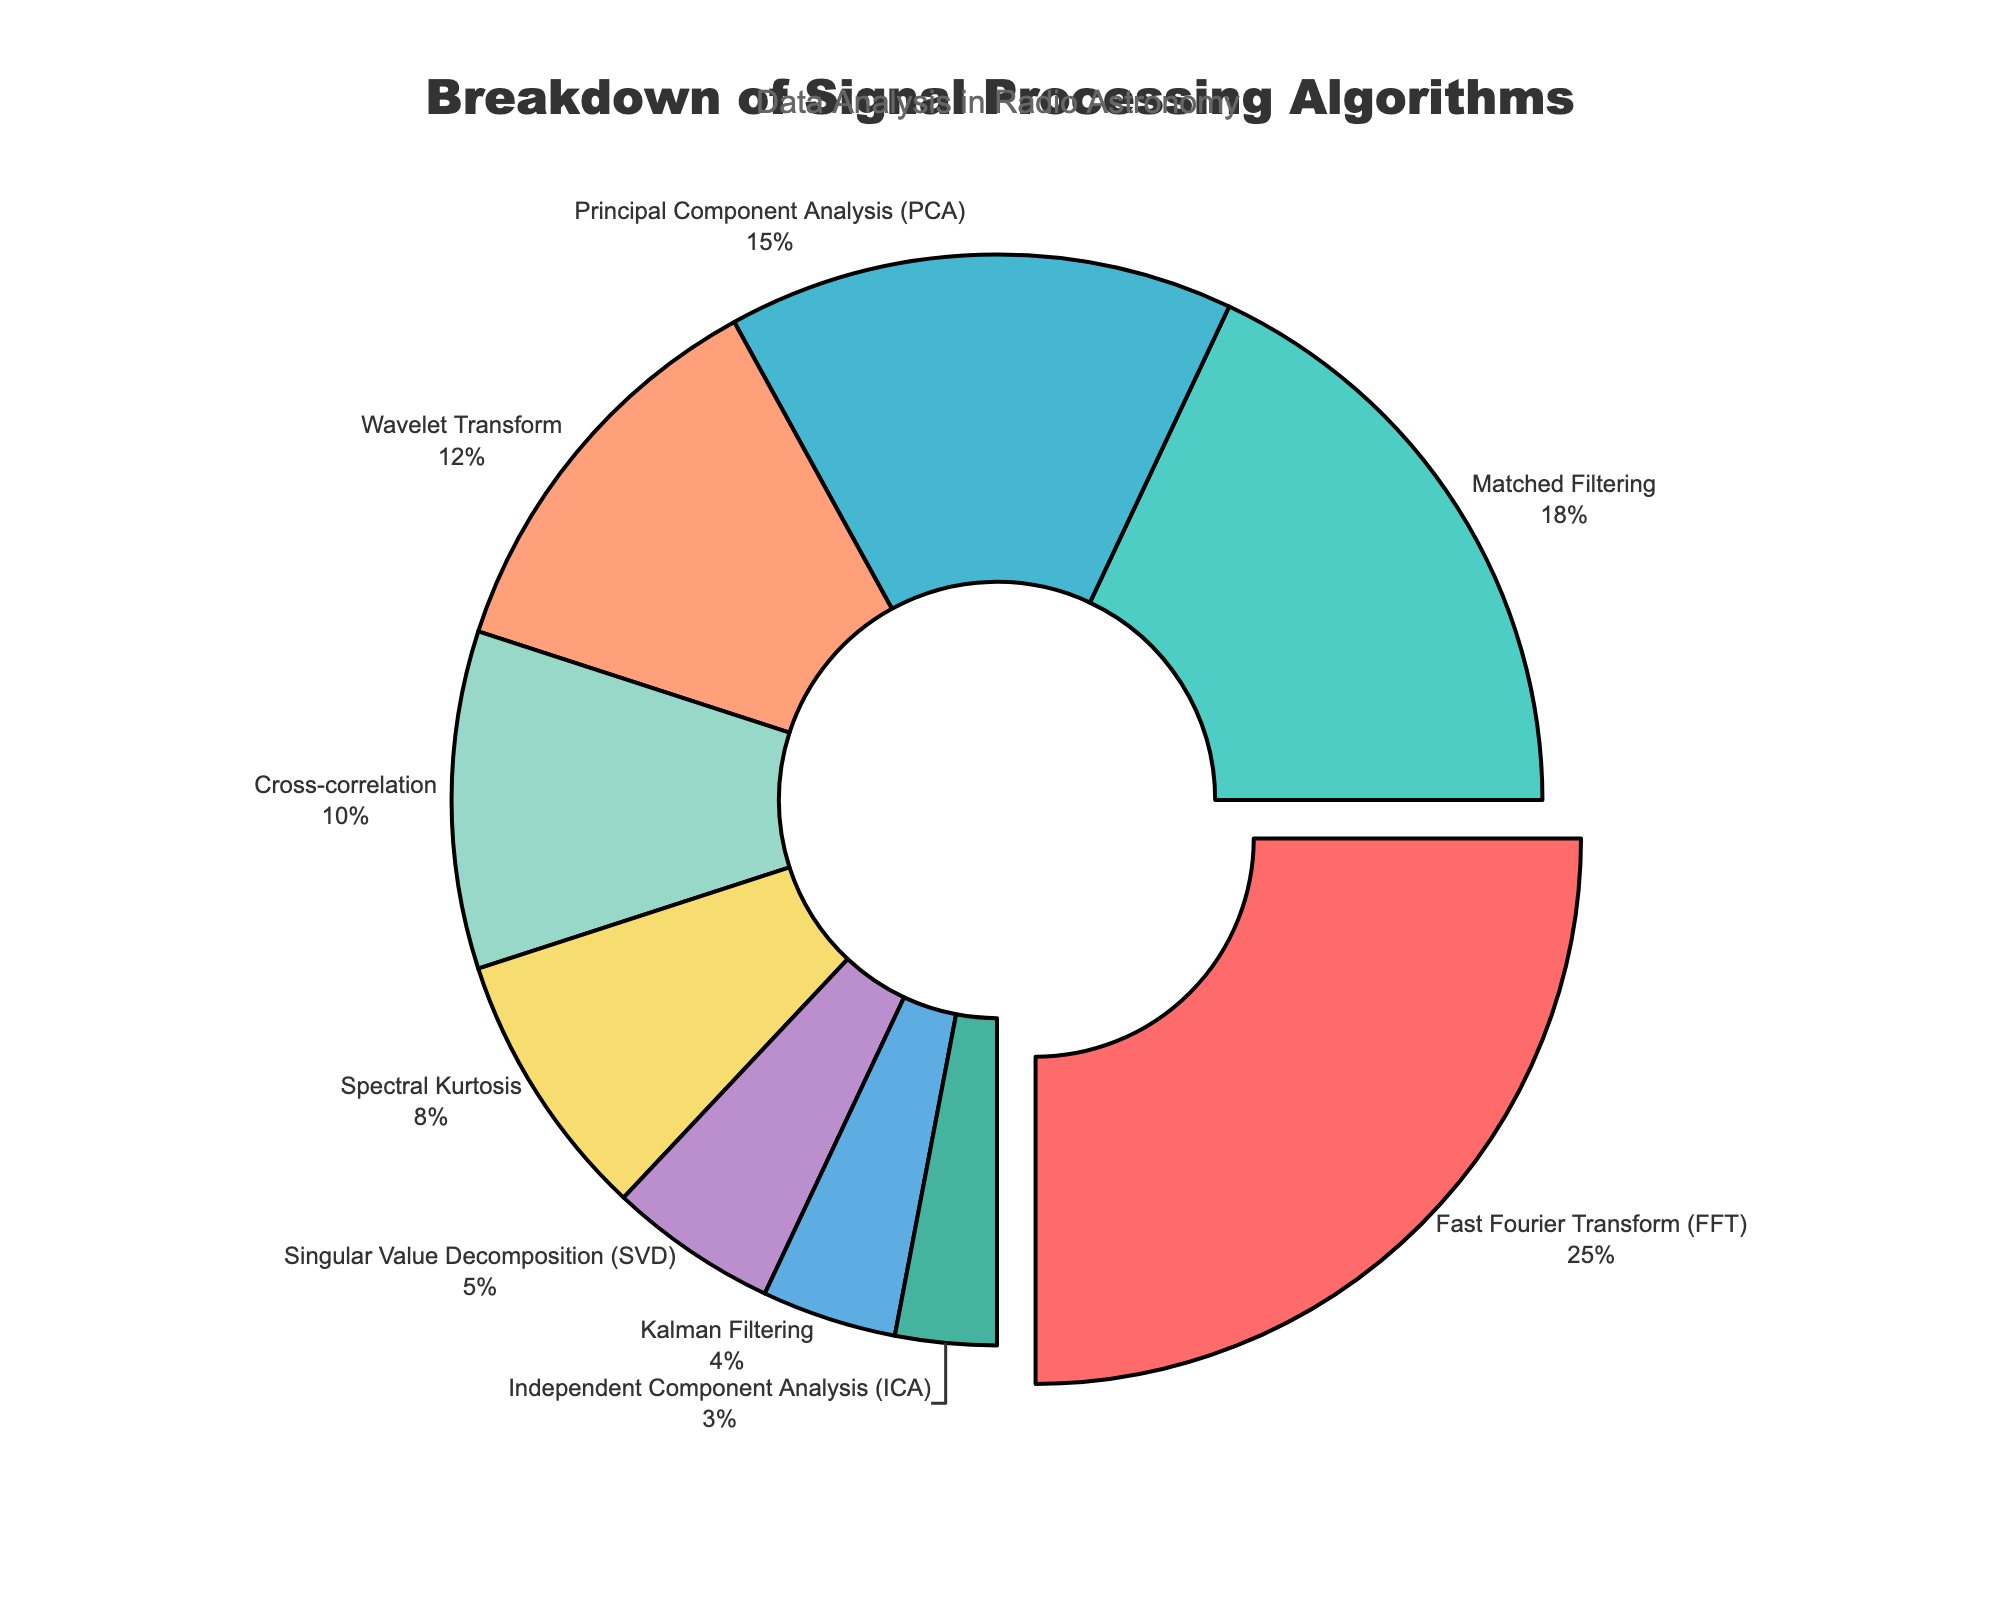What algorithm has the highest percentage? By looking at the pie chart, the largest segment, which is often the most visually prominent, represents the highest percentage. In this case, the Fast Fourier Transform (FFT) has the largest piece pulled slightly outward.
Answer: Fast Fourier Transform (FFT) Which two algorithms combined account for 33% of the total? To find the combination that sums to 33%, examine the percentages of the algorithms. Matched Filtering is 18% and Singular Value Decomposition (SVD) is 5%. Adding these two gives 18% + 15% = 33%.
Answer: Matched Filtering and Singular Value Decomposition (SVD) How much greater is the percentage of Wavelet Transform than that of Kalman Filtering? Wavelet Transform is 12%, and Kalman Filtering is 4%. Subtract 4% from 12% to find the difference.
Answer: 8% Which algorithm is represented by the largest segment that is not pulled outward? The pie chart has one segment pulled outward: Fast Fourier Transform (FFT). The largest segment that is not pulled outward is for Matched Filtering at 18%.
Answer: Matched Filtering Given the sum of percentages for PCA, Wavelet Transform, and Spectral Kurtosis, what is the combined percentage? Add the percentages of PCA (15%), Wavelet Transform (12%), and Spectral Kurtosis (8%) to get the total percentage. 15% + 12% + 8% = 35%.
Answer: 35% What is the smallest slice of the pie, and what percentage does it represent? The smallest slice is visually the smallest segment of the pie chart. Here, it is the Independent Component Analysis (ICA) at 3%.
Answer: Independent Component Analysis (ICA) How many algorithms account for less than 10% each? Looking at the pie chart, count the segments with percentages less than 10%. These are Spectral Kurtosis (8%), Singular Value Decomposition (SVD) (5%), Kalman Filtering (4%), and Independent Component Analysis (ICA) (3%). So, there are 4 such algorithms.
Answer: 4 What proportion of the total percentage is represented by cross-correlation and SVD combined? Cross-correlation is 10% and SVD is 5%. The sum is 10% + 5% = 15%. The proportion is 15%.
Answer: 15% Which algorithms together make up exactly half of the total percentage? To find algorithms that sum to 50%, considering combinations might be easier. FFT (25%) combined with PCA (15%) and Kalman Filtering (4%) gives 25% + 15% + 10% = 50%.
Answer: FFT, PCA, and Kalman Filtering 